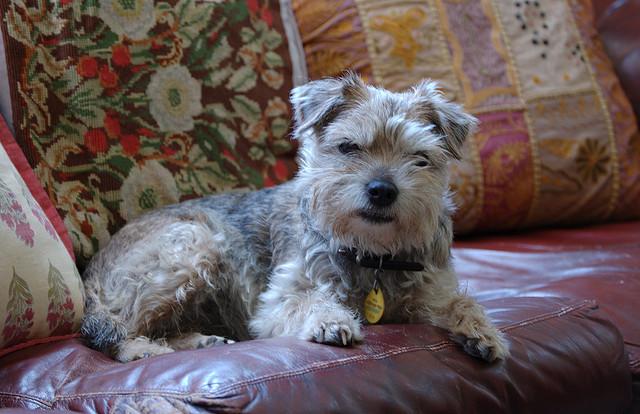What is the dog laying on?
Quick response, please. Couch. Is the dog smiling?
Short answer required. No. What kind of dog is this?
Write a very short answer. Terrier. Is this dog looking at the camera?
Be succinct. Yes. 